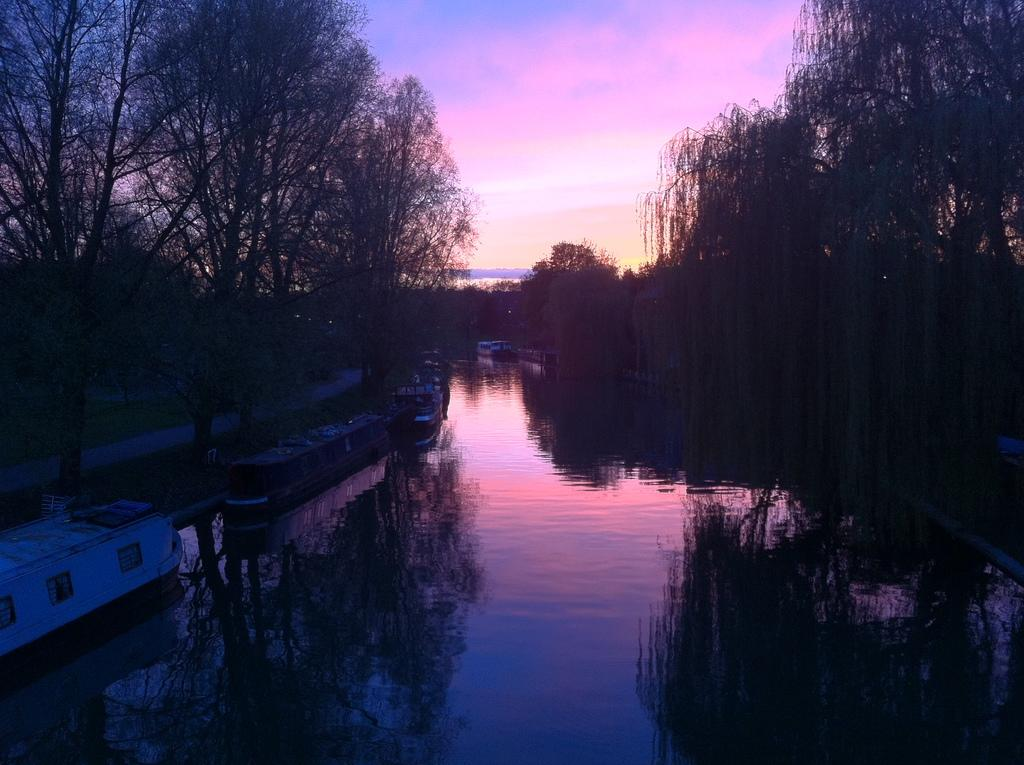What can be seen in the sky in the image? The sky is visible in the image, and there are clouds present. What type of vegetation is in the image? Trees and grass are present in the image. What is the body of water in the image used for? Boats are in the image, which suggests that the water is used for transportation or recreation. Can you describe the other objects in the image? There are a few other objects in the image, but their specific details are not mentioned in the provided facts. Where is the library located in the image? There is no library present in the image. What type of horse can be seen grazing in the grass? There is no horse present in the image. 